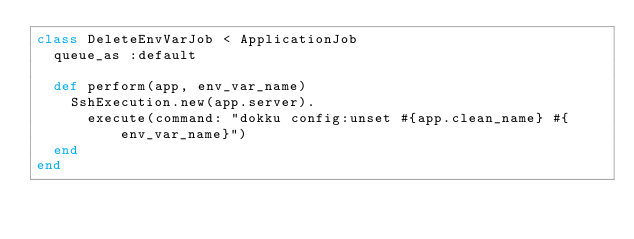<code> <loc_0><loc_0><loc_500><loc_500><_Ruby_>class DeleteEnvVarJob < ApplicationJob
  queue_as :default

  def perform(app, env_var_name)
    SshExecution.new(app.server).
      execute(command: "dokku config:unset #{app.clean_name} #{env_var_name}")
  end
end
</code> 